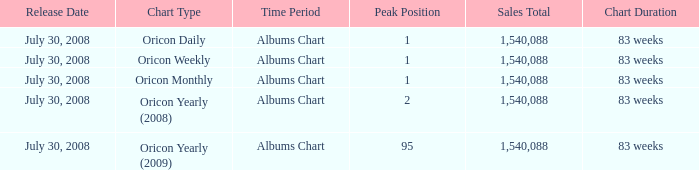What is the highest position with a sales total surpassing 1,540,088? 0.0. 